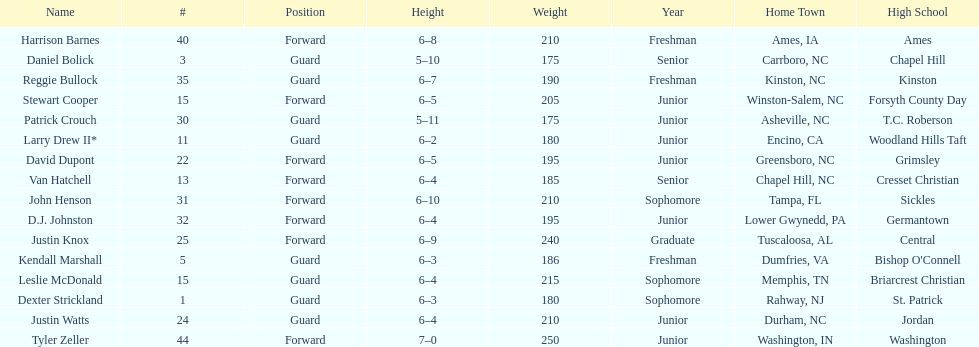Between justin knox and john henson, who was more elevated? John Henson. 